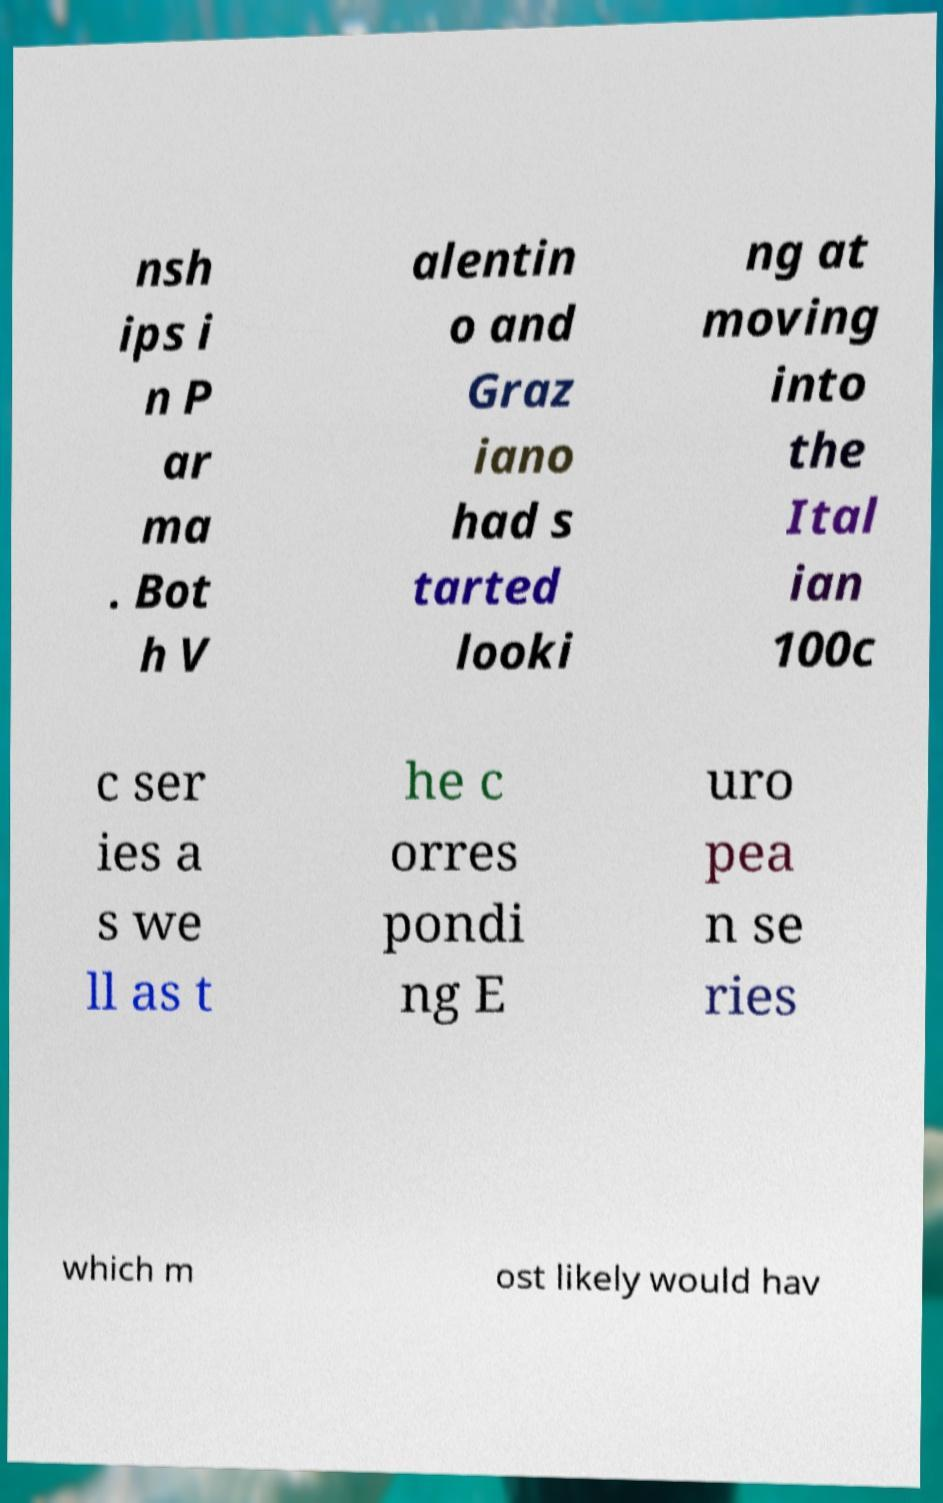What messages or text are displayed in this image? I need them in a readable, typed format. nsh ips i n P ar ma . Bot h V alentin o and Graz iano had s tarted looki ng at moving into the Ital ian 100c c ser ies a s we ll as t he c orres pondi ng E uro pea n se ries which m ost likely would hav 